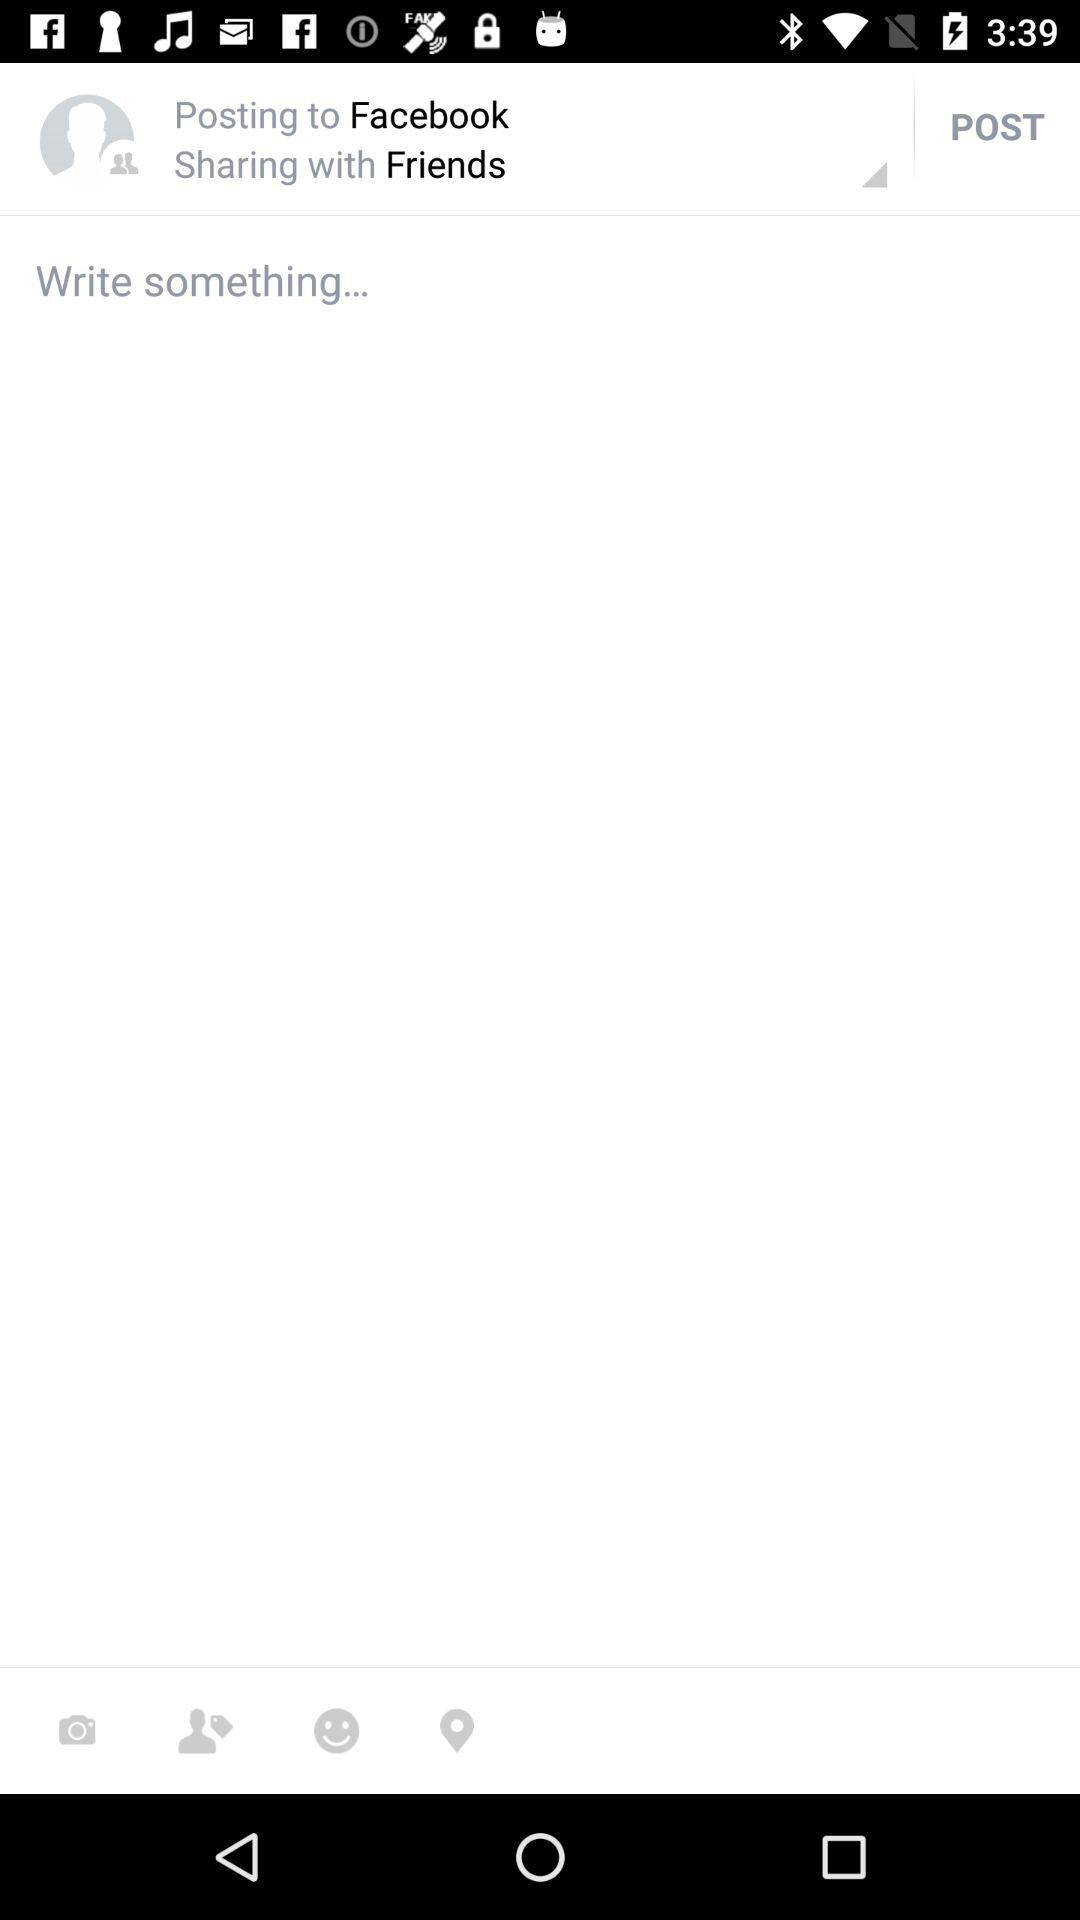With whom can I share the post? You can share the post with friends. 